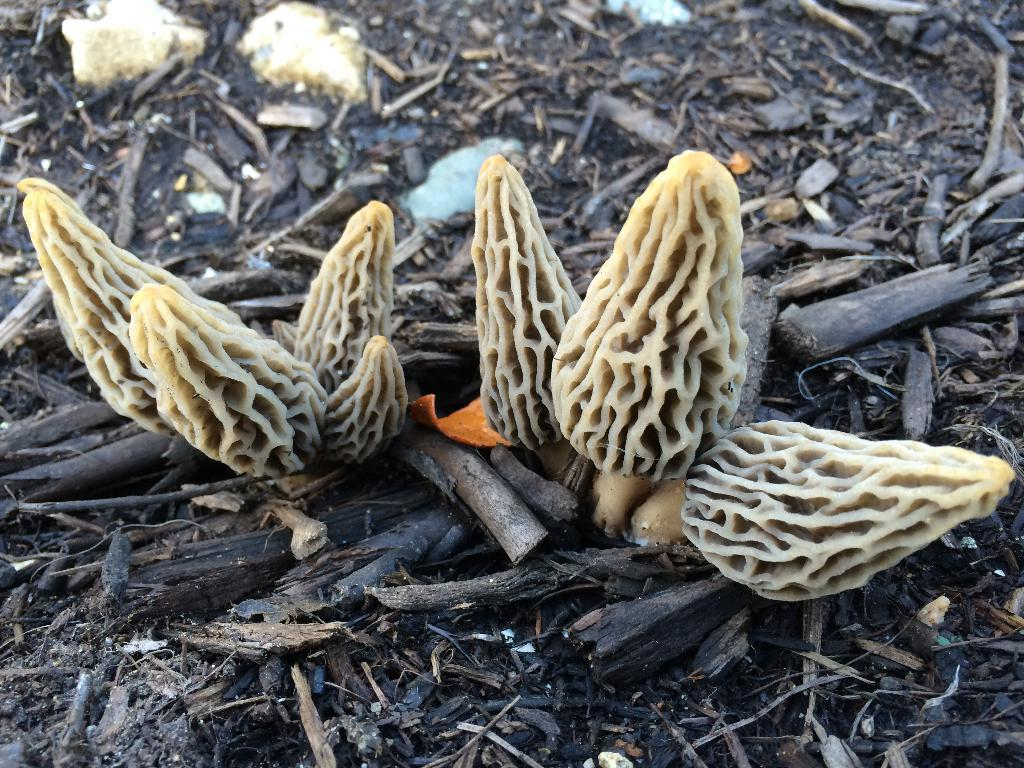What type of plants can be seen in the image? There are fungus plants in the image. Where are the fungus plants located? The fungus plants are on the land. What else can be found on the land in the image? Dry twigs are present on the land. What type of pies are being served on the land in the image? There are no pies present in the image; it features fungus plants and dry twigs on the land. What type of drink is being consumed by the fungus plants in the image? Fungus plants do not consume drinks, as they are not living organisms that require sustenance in the same way as animals or humans. 